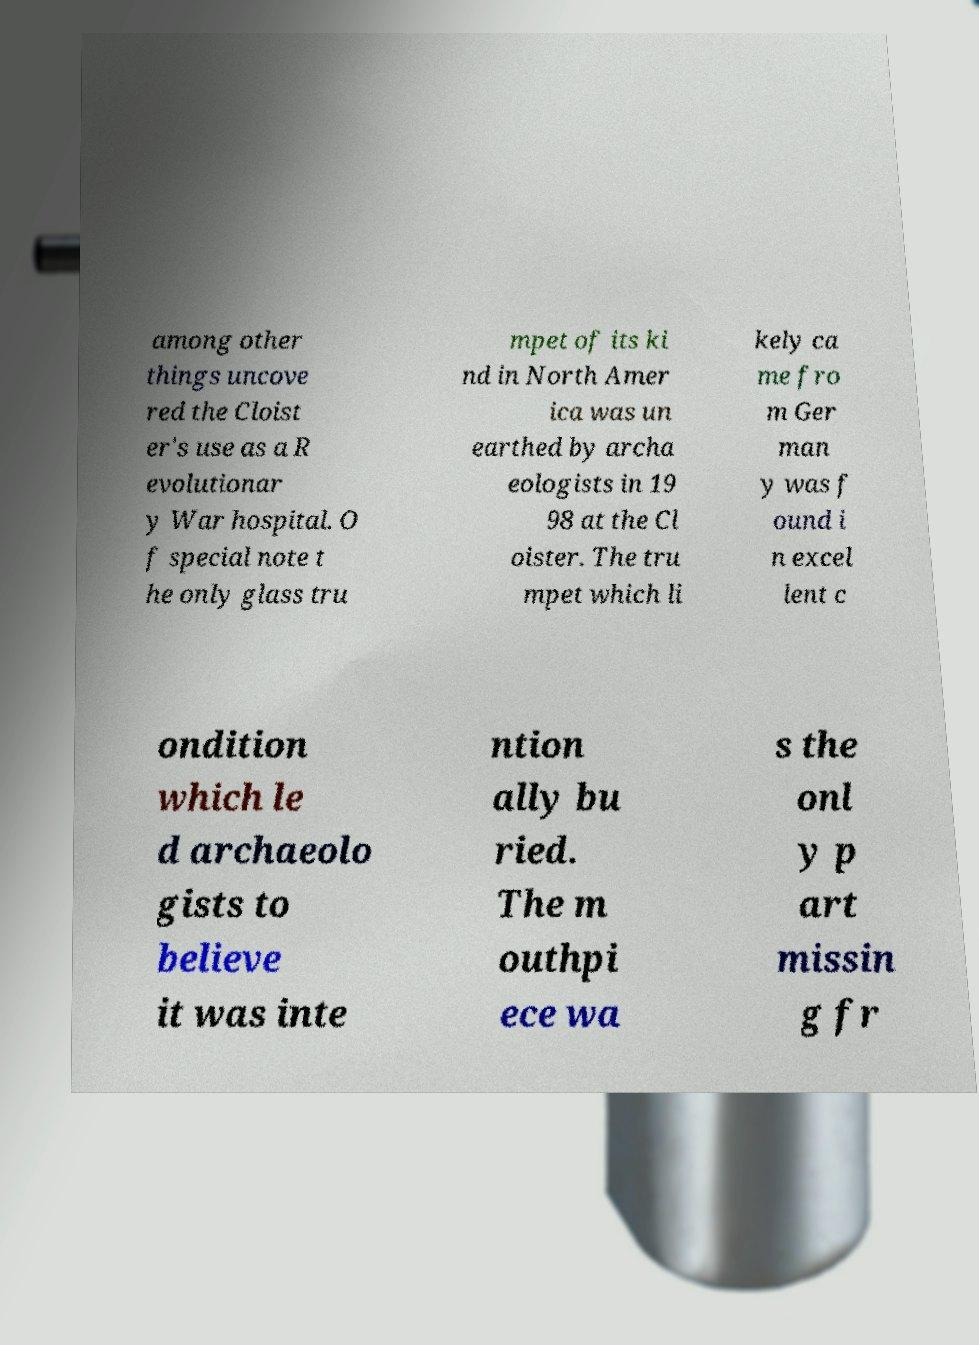What messages or text are displayed in this image? I need them in a readable, typed format. among other things uncove red the Cloist er's use as a R evolutionar y War hospital. O f special note t he only glass tru mpet of its ki nd in North Amer ica was un earthed by archa eologists in 19 98 at the Cl oister. The tru mpet which li kely ca me fro m Ger man y was f ound i n excel lent c ondition which le d archaeolo gists to believe it was inte ntion ally bu ried. The m outhpi ece wa s the onl y p art missin g fr 